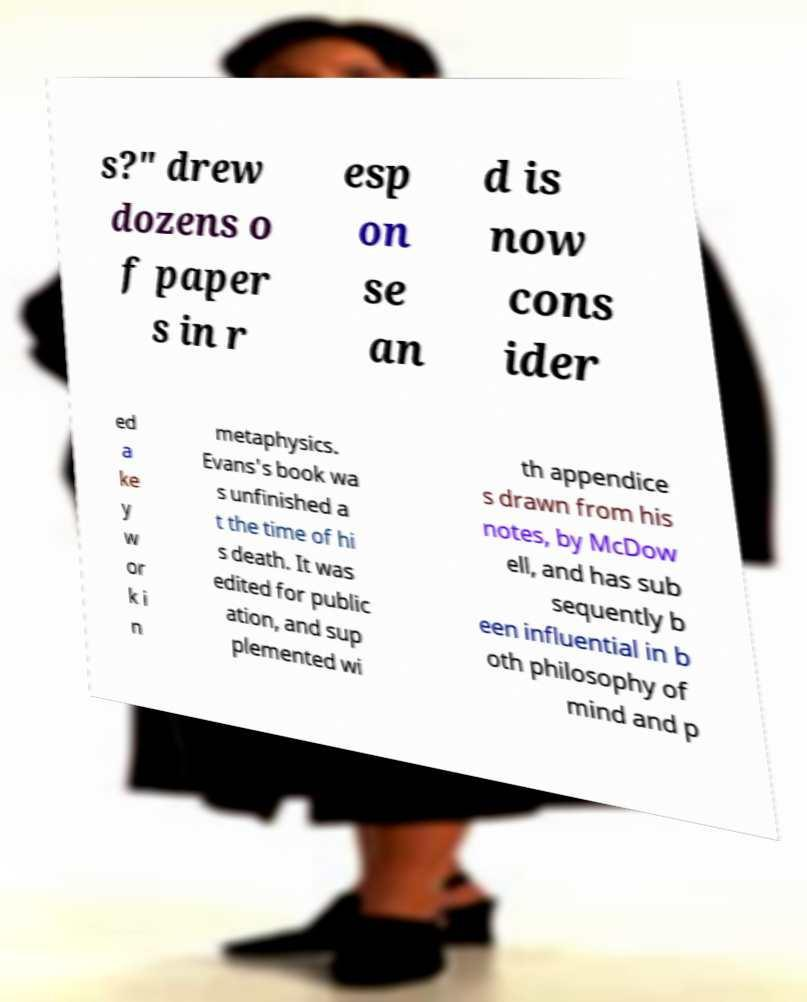Can you accurately transcribe the text from the provided image for me? s?" drew dozens o f paper s in r esp on se an d is now cons ider ed a ke y w or k i n metaphysics. Evans's book wa s unfinished a t the time of hi s death. It was edited for public ation, and sup plemented wi th appendice s drawn from his notes, by McDow ell, and has sub sequently b een influential in b oth philosophy of mind and p 